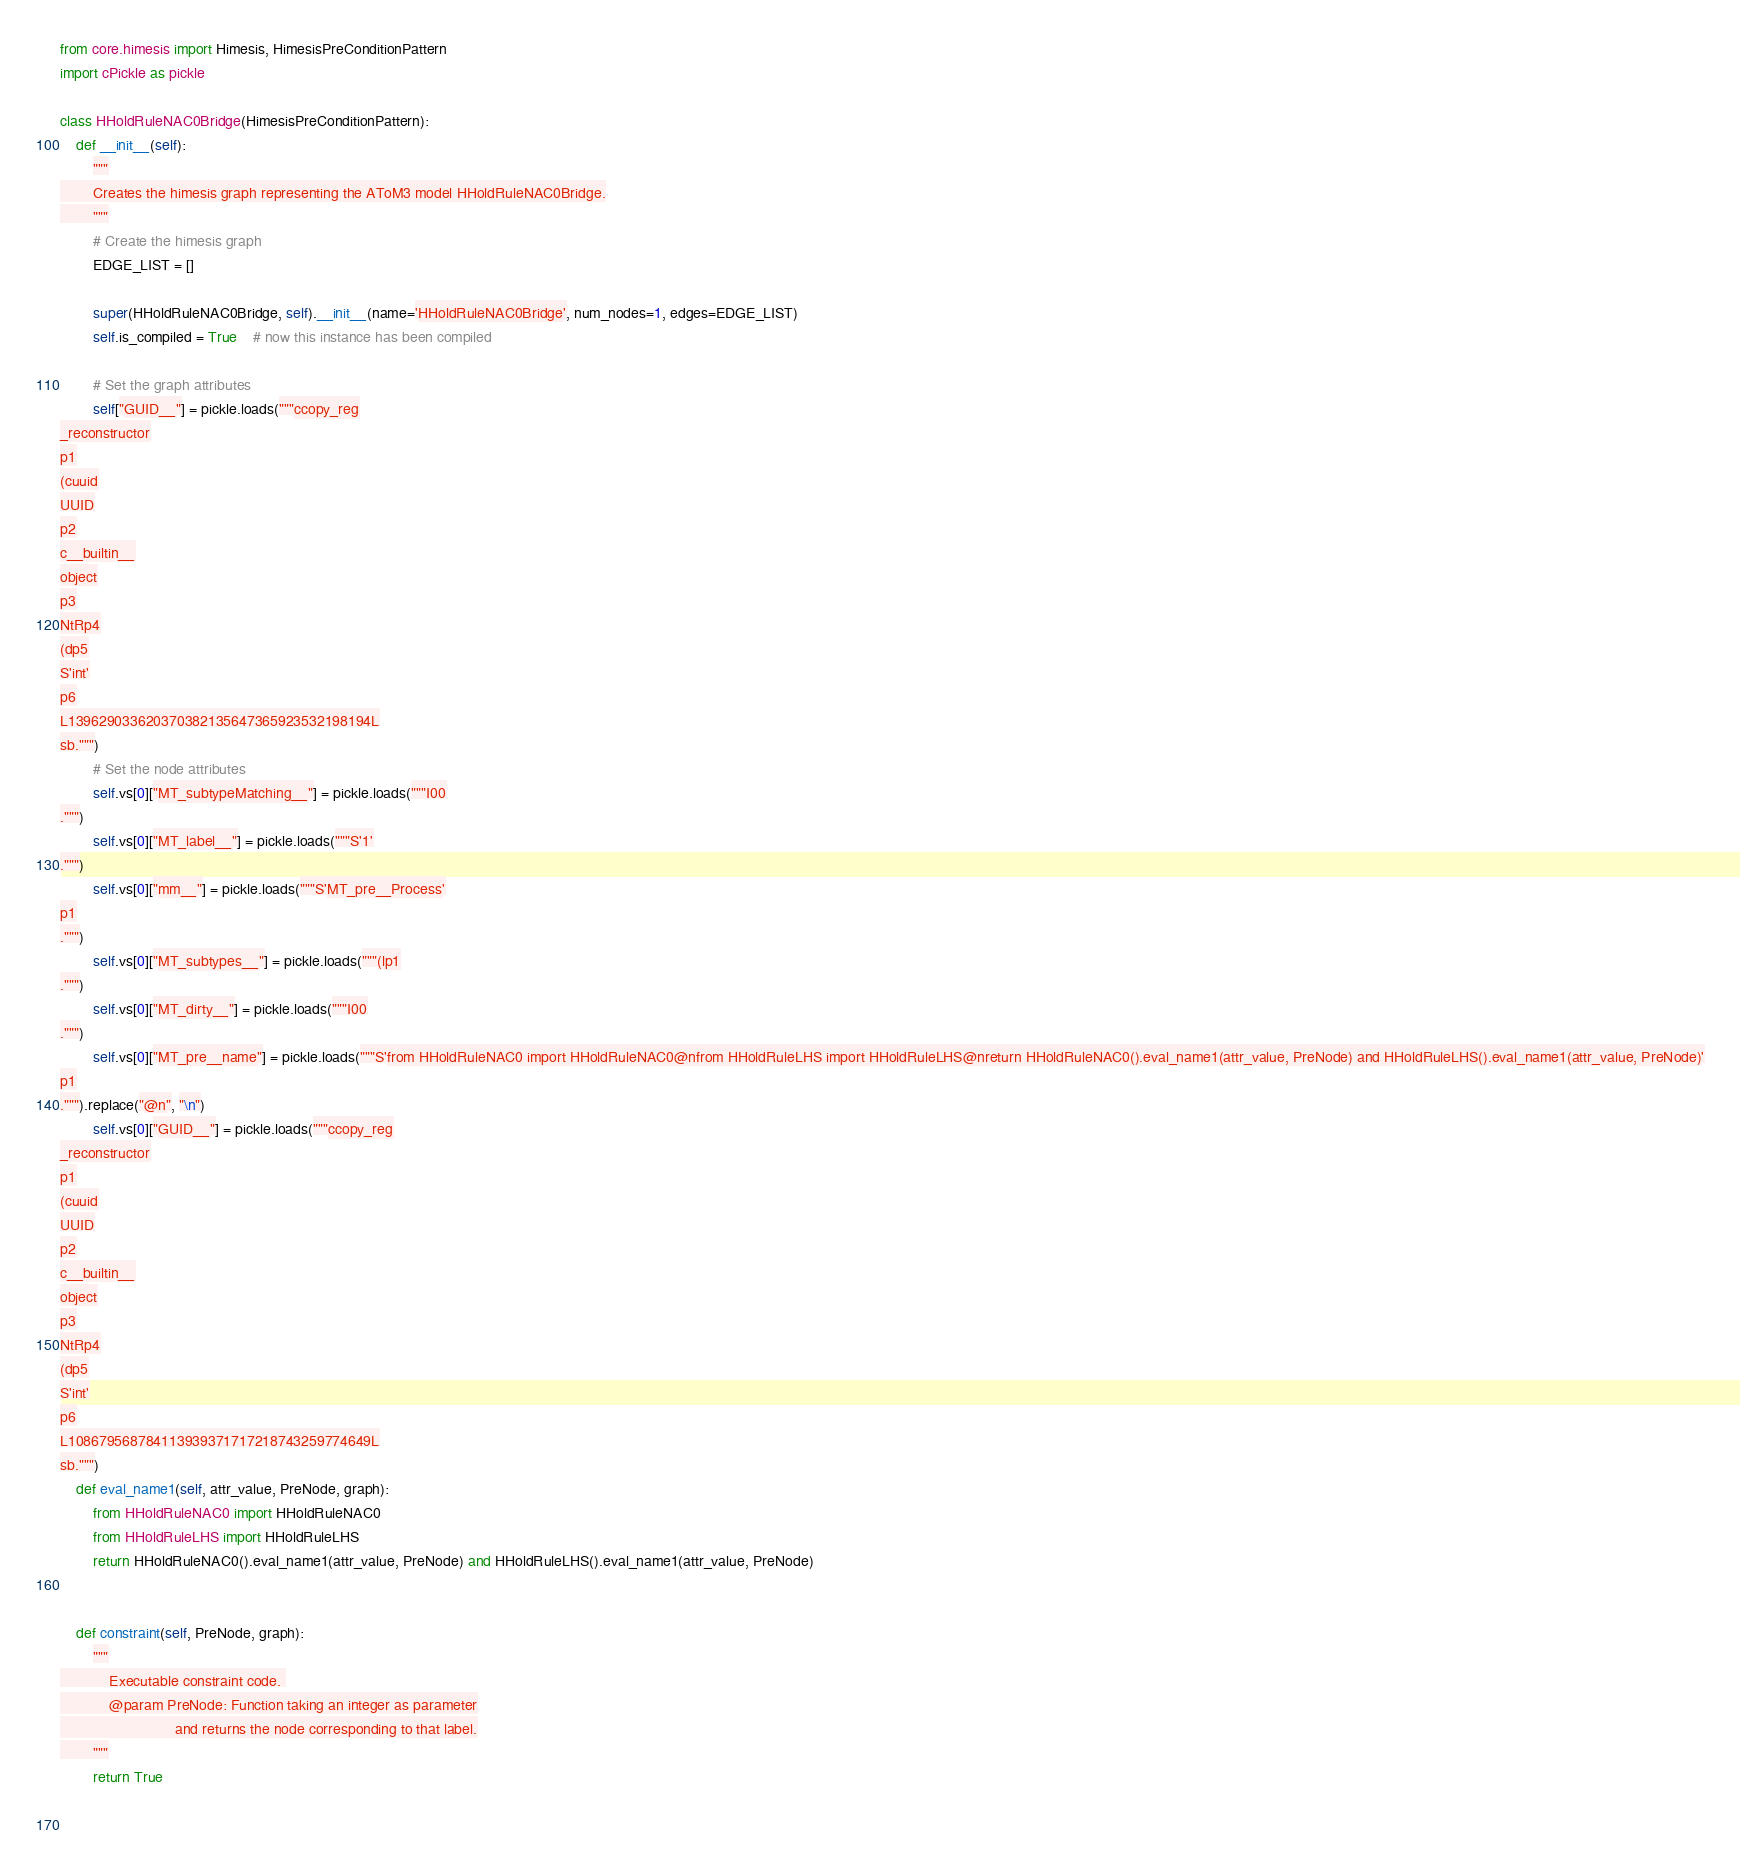Convert code to text. <code><loc_0><loc_0><loc_500><loc_500><_Python_>

from core.himesis import Himesis, HimesisPreConditionPattern
import cPickle as pickle

class HHoldRuleNAC0Bridge(HimesisPreConditionPattern):
    def __init__(self):
        """
        Creates the himesis graph representing the AToM3 model HHoldRuleNAC0Bridge.
        """
        # Create the himesis graph
        EDGE_LIST = []
        
        super(HHoldRuleNAC0Bridge, self).__init__(name='HHoldRuleNAC0Bridge', num_nodes=1, edges=EDGE_LIST)
        self.is_compiled = True    # now this instance has been compiled

        # Set the graph attributes
        self["GUID__"] = pickle.loads("""ccopy_reg
_reconstructor
p1
(cuuid
UUID
p2
c__builtin__
object
p3
NtRp4
(dp5
S'int'
p6
L139629033620370382135647365923532198194L
sb.""")
        # Set the node attributes
        self.vs[0]["MT_subtypeMatching__"] = pickle.loads("""I00
.""")
        self.vs[0]["MT_label__"] = pickle.loads("""S'1'
.""")
        self.vs[0]["mm__"] = pickle.loads("""S'MT_pre__Process'
p1
.""")
        self.vs[0]["MT_subtypes__"] = pickle.loads("""(lp1
.""")
        self.vs[0]["MT_dirty__"] = pickle.loads("""I00
.""")
        self.vs[0]["MT_pre__name"] = pickle.loads("""S'from HHoldRuleNAC0 import HHoldRuleNAC0@nfrom HHoldRuleLHS import HHoldRuleLHS@nreturn HHoldRuleNAC0().eval_name1(attr_value, PreNode) and HHoldRuleLHS().eval_name1(attr_value, PreNode)'
p1
.""").replace("@n", "\n")
        self.vs[0]["GUID__"] = pickle.loads("""ccopy_reg
_reconstructor
p1
(cuuid
UUID
p2
c__builtin__
object
p3
NtRp4
(dp5
S'int'
p6
L108679568784113939371717218743259774649L
sb.""")
    def eval_name1(self, attr_value, PreNode, graph):
        from HHoldRuleNAC0 import HHoldRuleNAC0
        from HHoldRuleLHS import HHoldRuleLHS
        return HHoldRuleNAC0().eval_name1(attr_value, PreNode) and HHoldRuleLHS().eval_name1(attr_value, PreNode)


    def constraint(self, PreNode, graph):
        """
            Executable constraint code. 
            @param PreNode: Function taking an integer as parameter
                            and returns the node corresponding to that label.
        """
        return True

        </code> 